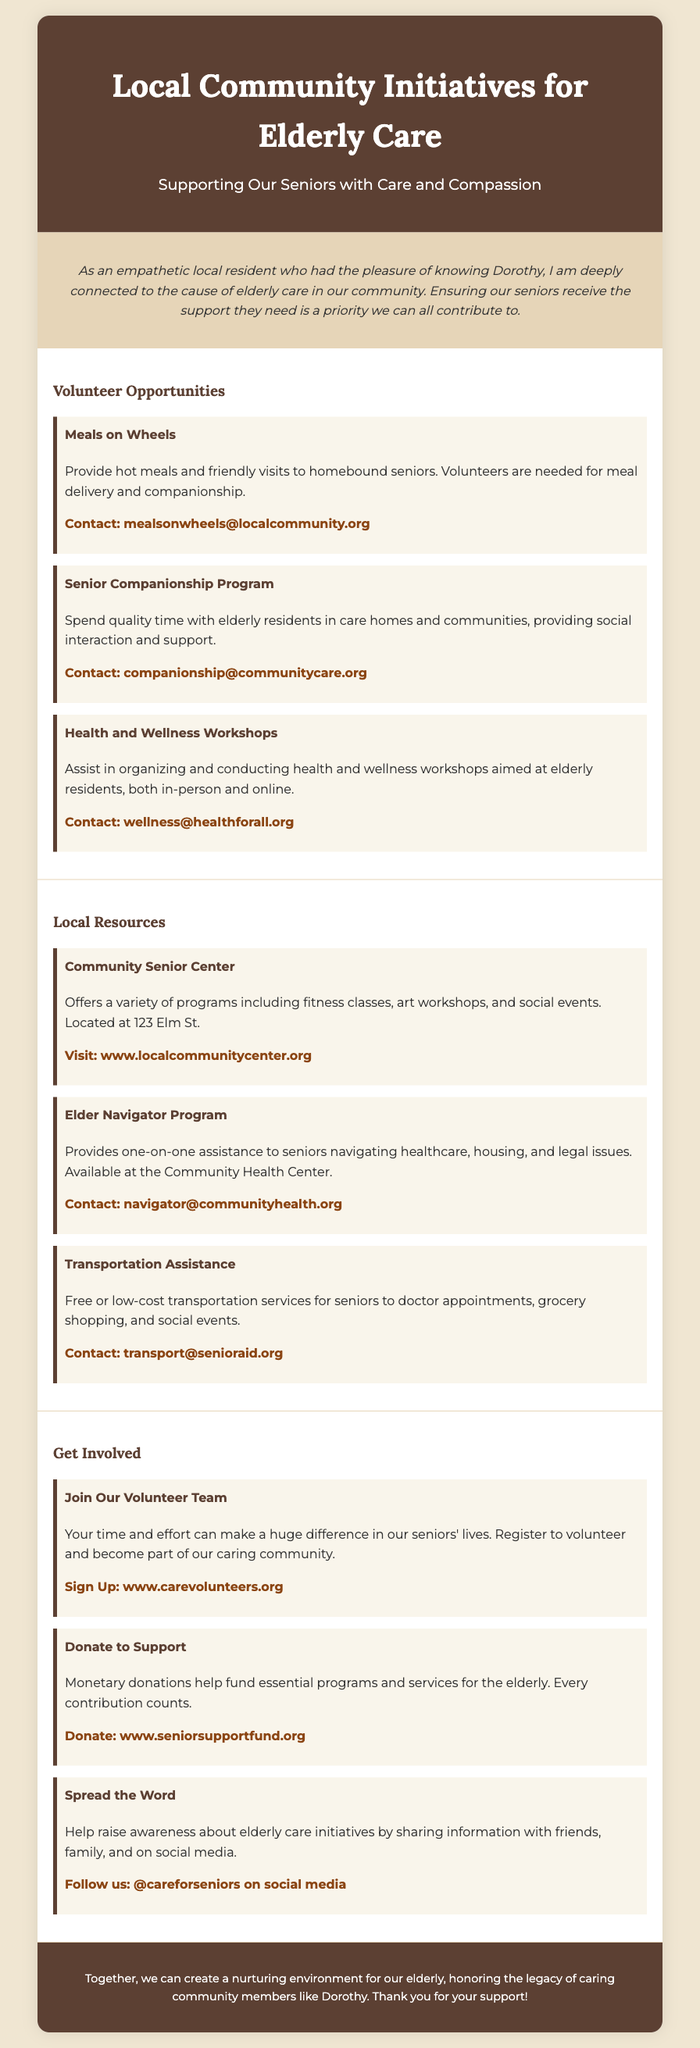what is the title of the poster? The title of the poster is stated at the top of the document.
Answer: Local Community Initiatives for Elderly Care who can you contact for Meals on Wheels? The contact information for Meals on Wheels is provided in the volunteer opportunities section.
Answer: mealsonwheels@localcommunity.org how many volunteer opportunities are listed in the document? The document lists three specific volunteer opportunities.
Answer: 3 what type of program is the Elder Navigator Program? The Elder Navigator Program is described in the local resources section of the document.
Answer: Assistance where is the Community Senior Center located? The location of the Community Senior Center is specifically mentioned in the resources section.
Answer: 123 Elm St which social media handle is mentioned for raising awareness? The poster gives a specific social media handle to follow for spreading the word.
Answer: @careforseniors what can you do to support the elderly care initiatives? Several ways to get involved are provided in the last section of the document.
Answer: Volunteer, Donate, Spread the Word who is the poster addressing as a local resident? The poster opens with a personal statement about knowing an individual.
Answer: Dorothy 